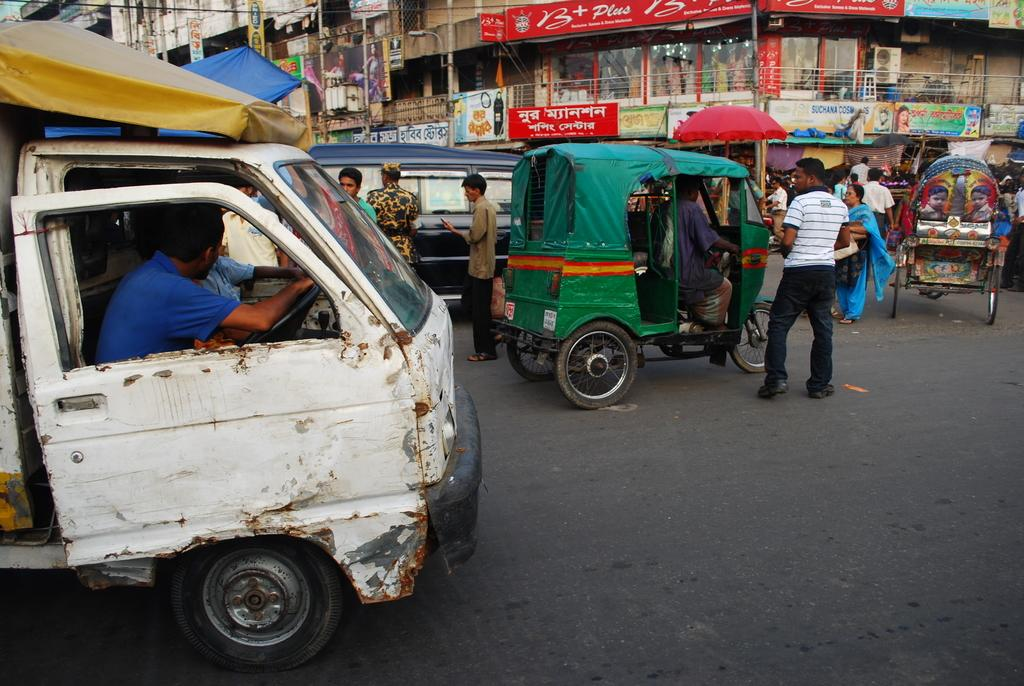Provide a one-sentence caption for the provided image. A sign with the word "Suchana" in blue letters hangs near a red umbrella. 